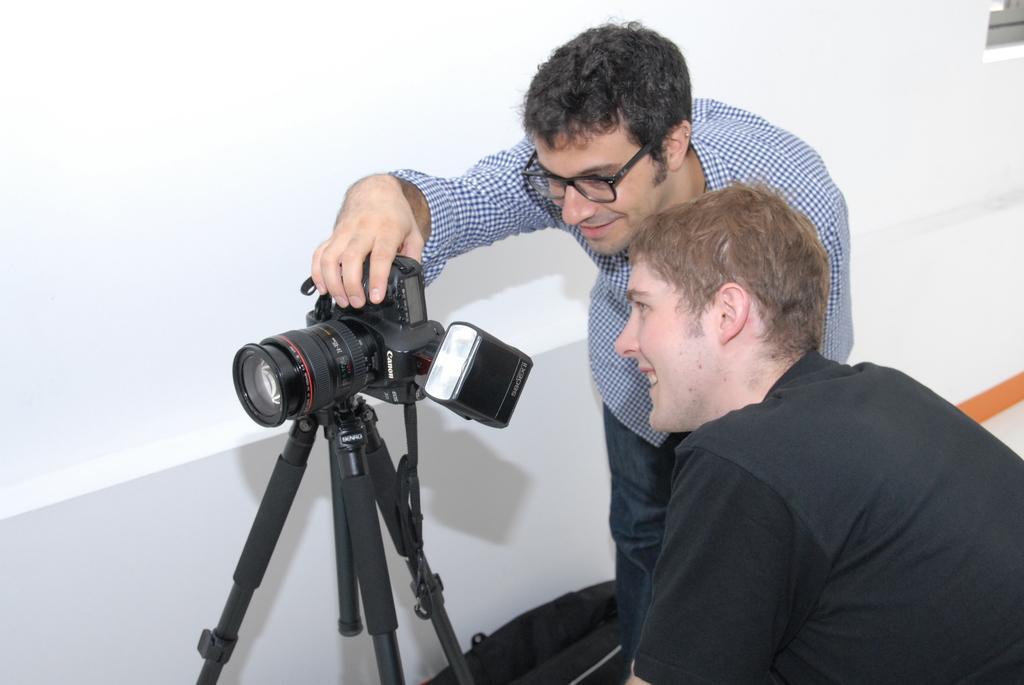Can you describe this image briefly? In this image, there is a person wearing clothes and holding a camera with his hand. There is an another person in the bottom right of the image wearing clothes and looking at the camera. 